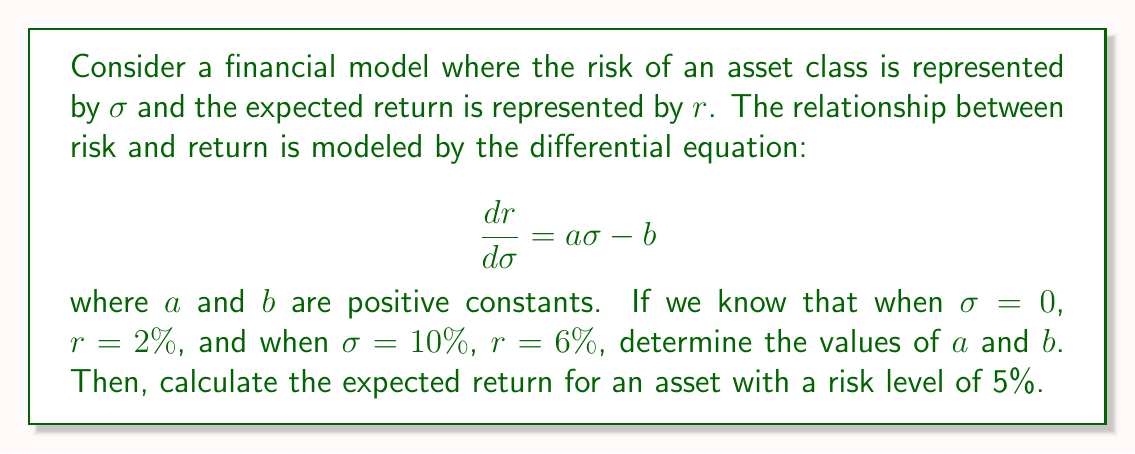Give your solution to this math problem. To solve this problem, we'll follow these steps:

1) First, we need to solve the differential equation:

   $$\frac{dr}{d\sigma} = a\sigma - b$$

   Integrating both sides:

   $$r = \frac{1}{2}a\sigma^2 - b\sigma + C$$

   where $C$ is the constant of integration.

2) We can use the given conditions to find $a$, $b$, and $C$:

   When $\sigma = 0$, $r = 2\%$:
   $$0.02 = C$$

   When $\sigma = 10\%$, $r = 6\%$:
   $$0.06 = \frac{1}{2}a(0.1)^2 - 0.1b + 0.02$$

3) Substituting $\sigma = 0$ and $r = 2\%$ into the general solution:

   $$0.02 = C$$

4) Now, using $\sigma = 10\%$ and $r = 6\%$:

   $$0.06 = \frac{1}{2}a(0.1)^2 - 0.1b + 0.02$$
   $$0.04 = 0.005a - 0.1b$$

5) We need another equation to solve for $a$ and $b$. We can get this by using the original differential equation at $\sigma = 10\%$:

   $$\frac{dr}{d\sigma} = a\sigma - b$$
   $$a(0.1) - b = \frac{0.06 - 0.02}{0.1} = 0.4$$
   $$0.1a - b = 0.4$$

6) Now we have a system of two equations:

   $$0.04 = 0.005a - 0.1b$$
   $$0.1a - b = 0.4$$

7) Solving this system:
   Multiply the first equation by 20:
   $$0.8 = 0.1a - 2b$$
   Subtract this from the second equation:
   $$b = 0.4$$
   Substituting back:
   $$0.1a - 0.4 = 0.4$$
   $$0.1a = 0.8$$
   $$a = 8$$

8) Now that we have $a$ and $b$, we can calculate the expected return for $\sigma = 5\%$:

   $$r = \frac{1}{2}(8)(0.05)^2 - (0.4)(0.05) + 0.02$$
   $$r = 0.01 - 0.02 + 0.02 = 0.01$$

Therefore, the expected return for an asset with a risk level of 5% is 1%.
Answer: $a = 8$, $b = 0.4$, and the expected return for an asset with a risk level of 5% is 1%. 